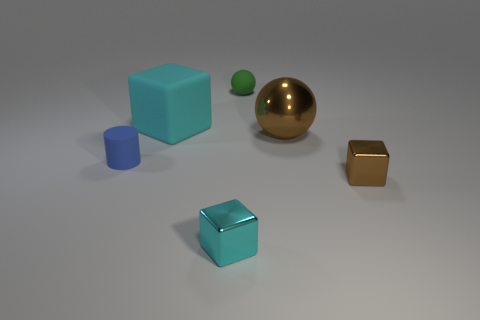How many tiny objects are either brown shiny spheres or brown cubes?
Your answer should be compact. 1. How many large red matte things are the same shape as the tiny cyan object?
Provide a short and direct response. 0. There is a tiny brown object behind the shiny object to the left of the big shiny sphere; what is its material?
Ensure brevity in your answer.  Metal. Is the number of green balls the same as the number of shiny things?
Your answer should be compact. No. There is a brown metallic thing behind the tiny blue matte thing; what size is it?
Provide a succinct answer. Large. How many red objects are either spheres or big spheres?
Provide a succinct answer. 0. Is there anything else that has the same material as the big cube?
Your response must be concise. Yes. What is the material of the other big thing that is the same shape as the green rubber thing?
Your answer should be compact. Metal. Is the number of brown spheres that are right of the green sphere the same as the number of metallic objects?
Offer a terse response. No. How big is the cube that is on the right side of the cyan rubber block and left of the tiny brown metallic object?
Give a very brief answer. Small. 